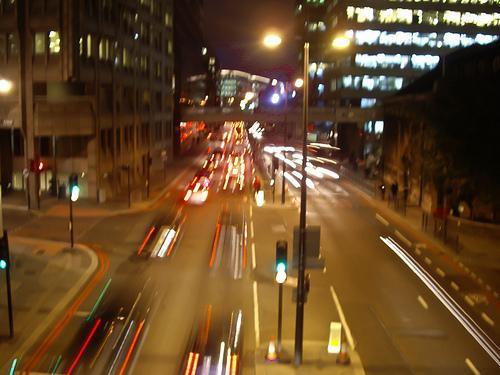Write a sentence about the key elements and actions in the picture. Cars move on a busy street with green streetlights and buildings with shining windows at night. Create a sentence about the general environment of the image. It is nighttime in the city with busy streets, illuminated buildings, and green streetlights. Provide a brief description of the picture's main subject and its surrounding details. Active street at night with several cars, glowing streetlights, and lighted buildings nearby. Describe the primary aspect of the image and what is happening around it. Night street scene with cars in motion, bright streetlights, and buildings with gleaming windows. Explain the overall atmosphere of the image and mention a key detail. A bustling urban street at night with a green traffic light in the middle of the road. Describe what happens on the road in the image. Numerous cars are moving on the road, with green traffic lights and yellow dotted lines visible. Provide a brief explanation about the picture's main elements and their actions. Street full of moving cars, lit-up buildings, and green streetlights during nighttime. Mention the primary element in the picture and its action. A street filled with cars in motion, with buildings having lit windows by the sides. In simple terms, discuss the primary aspect of the picture and what is happening. Busy street at night with many cars, lit buildings, and green traffic lights. Tell me about the main scene in the image using a few keywords. Nighttime, city street, moving cars, illuminated windows, green traffic light. 